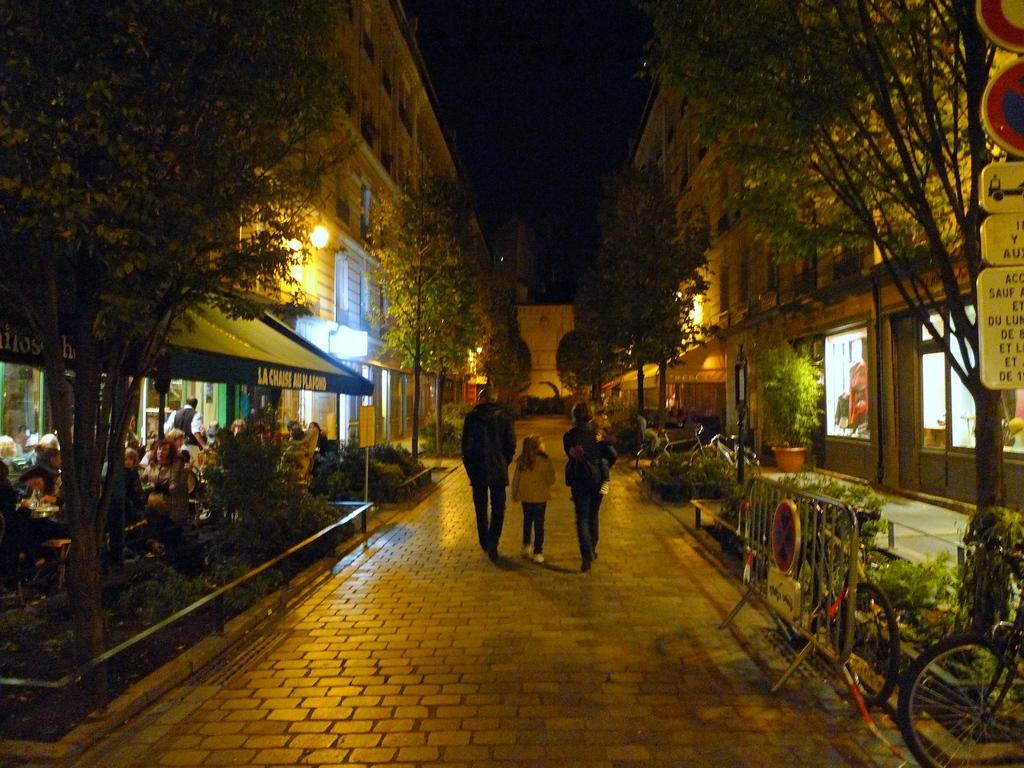How would you summarize this image in a sentence or two? In this image, we can see people walking on the road and in the background, there are trees, buildings, lights, poles, boards, plants and some other people and there are chairs and tables and we can see a railing and some bicycles. 